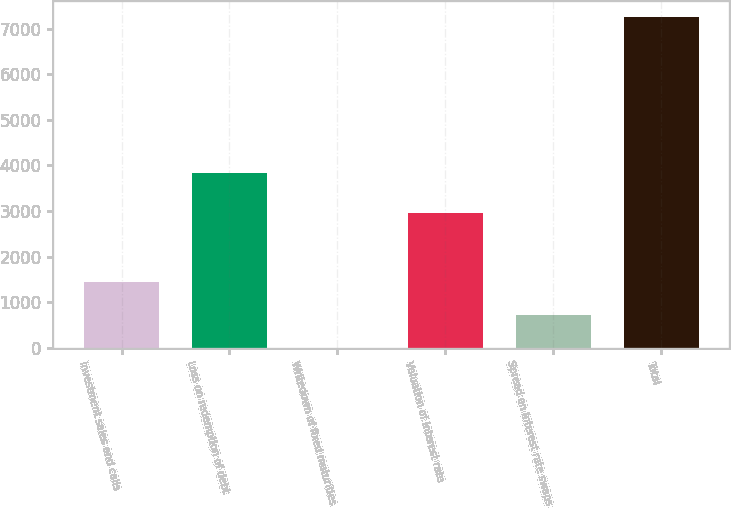<chart> <loc_0><loc_0><loc_500><loc_500><bar_chart><fcel>Investment sales and calls<fcel>Loss on redemption of debt<fcel>Writedown of fixed maturities<fcel>Valuation of interest rate<fcel>Spread on interest rate swaps<fcel>Total<nl><fcel>1453.08<fcel>3830<fcel>2.86<fcel>2956<fcel>727.97<fcel>7254<nl></chart> 